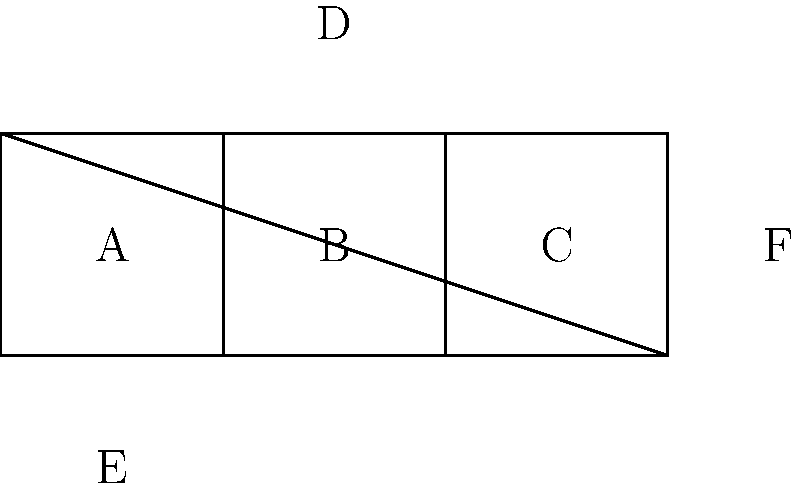During a quick break at work, you stumble upon this spatial reasoning puzzle. Which of the folded cubes (1, 2, 3, or 4) correctly represents the given unfolded shape? Consider the relative positions of faces A, B, C, D, E, and F. To solve this puzzle efficiently, let's follow these steps:

1. Identify the base face: Face B is the central face, so it will be the bottom of the cube.

2. Analyze adjacent faces:
   - Face A is to the left of B
   - Face C is to the right of B
   - Face D is above B
   - Face E is below B
   - Face F is to the right of C

3. Determine the correct arrangement:
   - A and C should be opposite each other
   - D and E should be opposite each other
   - F should be opposite A

4. Examine the given options:
   - Cube 1: Incorrect, as F is adjacent to A
   - Cube 2: Correct, all face positions match our analysis
   - Cube 3: Incorrect, as C is not opposite A
   - Cube 4: Incorrect, as E is not opposite D

5. Conclude that Cube 2 is the correct representation of the unfolded shape.

This quick analysis allows for a swift decision, suitable for a busy professional with limited time.
Answer: 2 